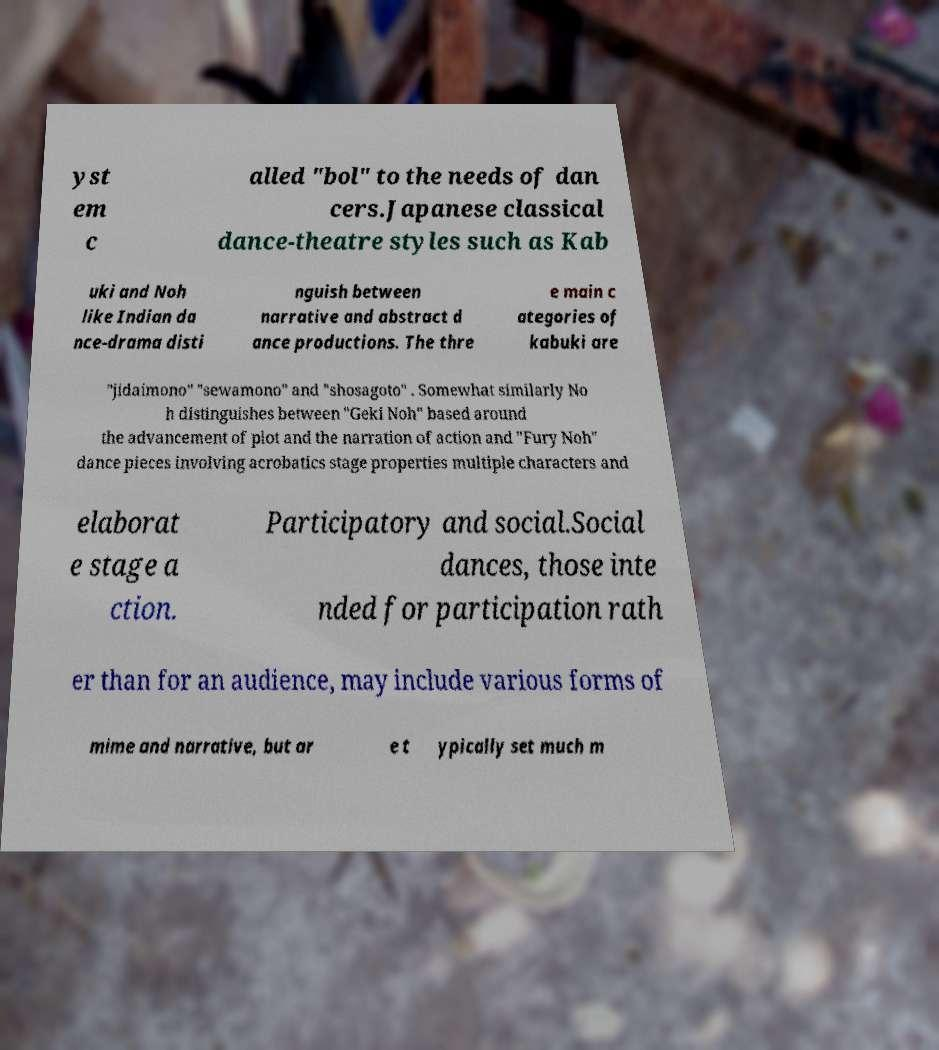I need the written content from this picture converted into text. Can you do that? yst em c alled "bol" to the needs of dan cers.Japanese classical dance-theatre styles such as Kab uki and Noh like Indian da nce-drama disti nguish between narrative and abstract d ance productions. The thre e main c ategories of kabuki are "jidaimono" "sewamono" and "shosagoto" . Somewhat similarly No h distinguishes between "Geki Noh" based around the advancement of plot and the narration of action and "Fury Noh" dance pieces involving acrobatics stage properties multiple characters and elaborat e stage a ction. Participatory and social.Social dances, those inte nded for participation rath er than for an audience, may include various forms of mime and narrative, but ar e t ypically set much m 